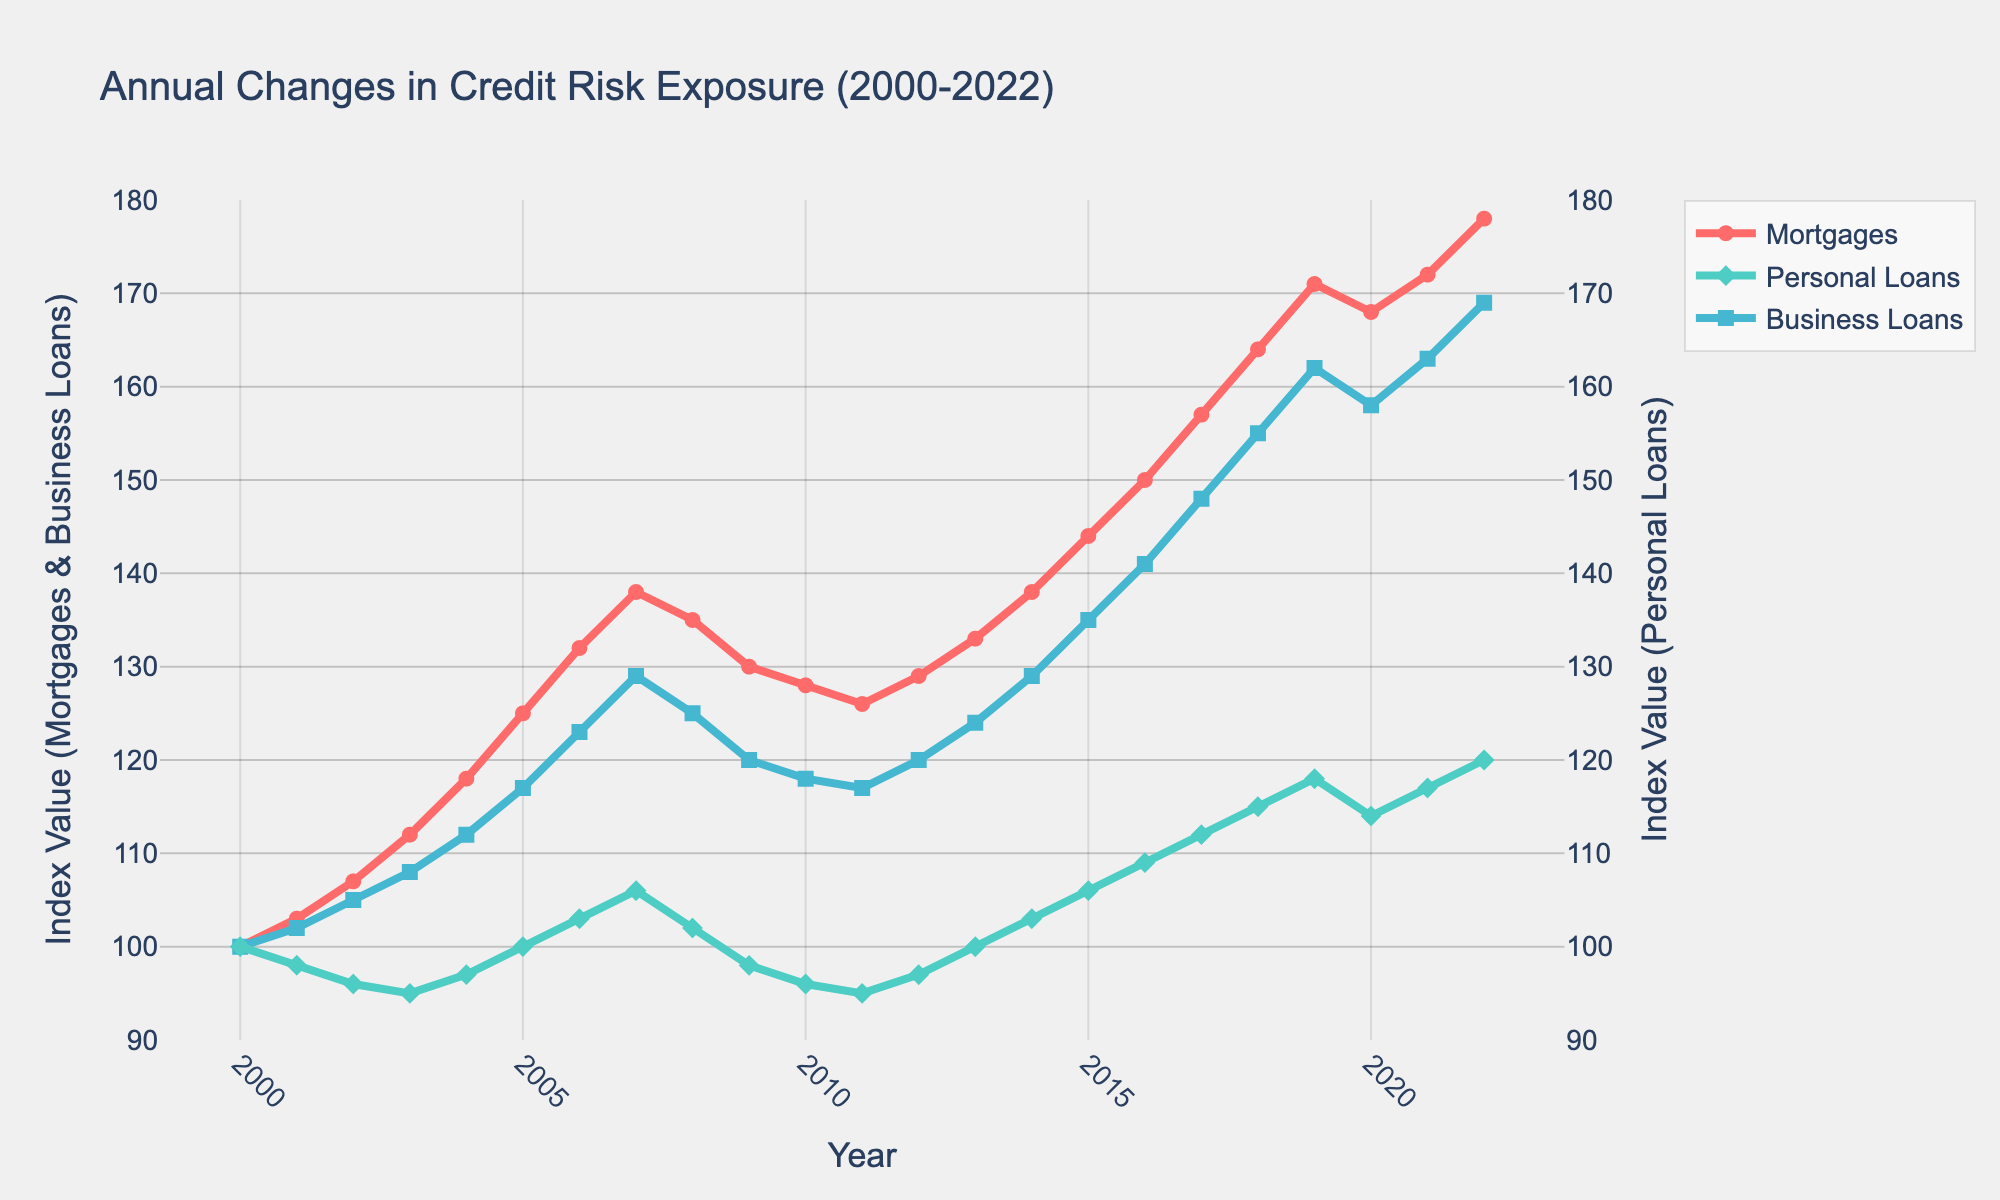What year did mortgage credit risk exposure peak? By examining the trend line for mortgages (red), we note the highest index value in 2022, at 178.
Answer: 2022 Which loan category had the most consistent growth over the given period? Comparing the plotted lines, we see that mortgages (red) show the most consistent upward trend without major drops.
Answer: Mortgages How did personal loans' credit risk exposure change from 2007 to 2009 compared to business loans? Personal loans (green) decreased from 106 in 2007 to 98 in 2009, an absolute change of -8. Business loans (blue) decreased from 129 to 120, an absolute change of -9. Comparing the changes, personal loans decreased by 1 index point less.
Answer: -8 vs. -9 In which year did business loans have the same credit risk exposure as mortgages? Aligning the blue line (business loans) with the red line (mortgages), they intersect at around 2012, with both having an index value of approximately 129 and 126 respectively.
Answer: 2012 What is the visual difference in the trend between personal loans and business loans from 2009 to 2015? Personal loans (green) had a gradual increase from 98 to 106, while business loans (blue) had a sharper increase from 120 to 135, indicating a steeper climb for business loans.
Answer: Sharper climb for business loans From 2008 to 2009, which loan category saw the largest drop in credit risk exposure? By comparing the slopes and values from 2008 to 2009, the largest decrease is visible in mortgages (red), from 138 to 130, a drop of 8 points.
Answer: Mortgages Which year showed a slight decline in mortgage credit risk exposure, and what was the following trend in the subsequent years? The red line for mortgages drops slightly from 171 in 2019 to 168 in 2020 but then rises again in subsequent years, reaching 178 by 2022.
Answer: 2019, rise Between which years did personal loans' credit risk exposure remain unchanged? Observing the green line, we see that from 2010 to 2011, the index remained constant at 95.
Answer: 2010-2011 Comparing the index values in 2004, which loan category had the least credit risk exposure, and is it consistent with the start of the year 2000? In 2004, personal loans (green) had an index value of 97, which is the lowest among the three categories. This consistency is observed starting in 2000 at an index value of 100.
Answer: Personal loans, Yes 